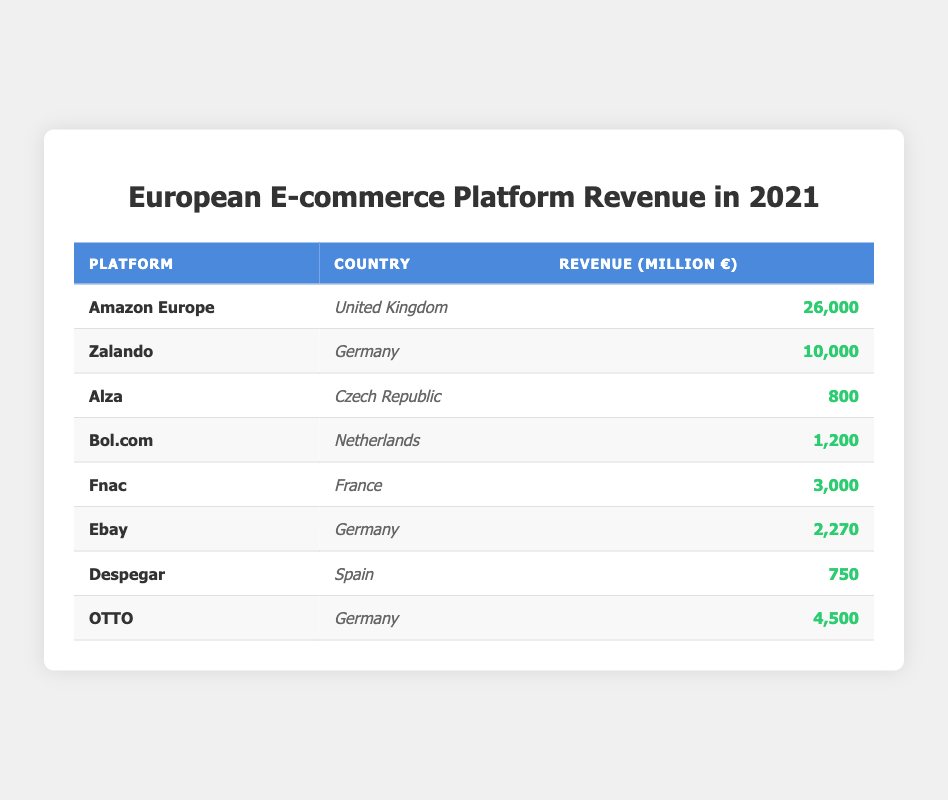What is the revenue of Amazon Europe? The table shows that Amazon Europe generated a revenue of 26,000 million euros in the United Kingdom.
Answer: 26,000 million euros Which platform from Germany has the highest revenue? By comparing the revenue figures for the platforms in Germany, Zalando has 10,000 million euros, OTTO has 4,500 million euros, and Ebay has 2,270 million euros. Therefore, Zalando has the highest revenue among them.
Answer: Zalando Is the revenue of Alza greater than 1,000 million euros? The revenue of Alza, as stated in the table, is 800 million euros. Since 800 million is less than 1,000 million, the statement is false.
Answer: No What is the total revenue generated by the German platforms? The revenue for the German platforms is as follows: Zalando (10,000 million euros), Ebay (2,270 million euros), and OTTO (4,500 million euros). Summing these gives 10,000 + 2,270 + 4,500 = 16,770 million euros. Therefore, the total revenue from German platforms is 16,770 million euros.
Answer: 16,770 million euros Is Fnac the only platform in France? The table shows that Fnac is the only platform listed for France, with a revenue of 3,000 million euros. Since no other platforms are mentioned for France, the statement is true.
Answer: Yes What is the average revenue of the listed platforms in the Czech Republic and Spain? Alza from the Czech Republic has a revenue of 800 million euros, and Despegar from Spain has a revenue of 750 million euros. The average is calculated by summing the revenues: 800 + 750 = 1,550 million euros, and then dividing by the number of platforms (2). Thus, the average is 1,550 / 2 = 775 million euros.
Answer: 775 million euros Which country has the second highest revenue from e-commerce platforms? The table indicates the following revenues: United Kingdom (26,000 million euros), Germany (16,770 million euros), Czech Republic (800 million euros), Netherlands (1,200 million euros), France (3,000 million euros), and Spain (750 million euros). Germany has the second highest revenue at 16,770 million euros after the United Kingdom.
Answer: Germany What platform generates fewer than 1,000 million euros? According to the data, Alza with 800 million euros and Despegar with 750 million euros both generate revenue below 1,000 million euros.
Answer: Alza and Despegar 